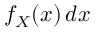<formula> <loc_0><loc_0><loc_500><loc_500>f _ { X } ( x ) \, d x</formula> 